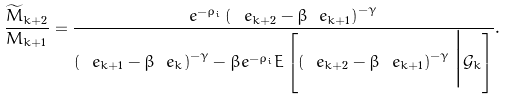Convert formula to latex. <formula><loc_0><loc_0><loc_500><loc_500>\frac { \widetilde { M } _ { k + 2 } } { M _ { k + 1 } } = \frac { e ^ { - \rho _ { i } } \left ( \ e _ { k + 2 } - \beta \ e _ { k + 1 } \right ) ^ { - \gamma } } { \left ( \ e _ { k + 1 } - \beta \ e _ { k } \right ) ^ { - \gamma } - \beta e ^ { - \rho _ { i } } E \left [ \left ( \ e _ { k + 2 } - \beta \ e _ { k + 1 } \right ) ^ { - \gamma } \Big | \mathcal { G } _ { k } \right ] } .</formula> 